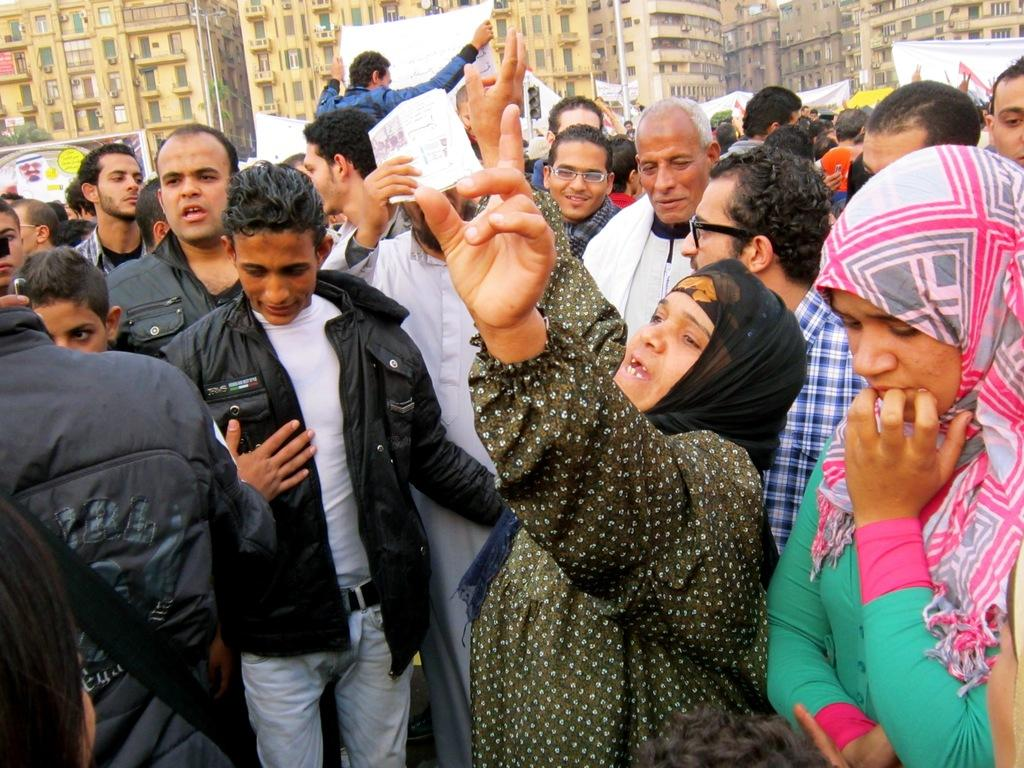What is the main subject of the image? The main subject of the image is a group of people. What are some of the people in the group holding? Some people in the group are holding white objects. What can be seen in the distance behind the group? There are buildings in the background of the image. What type of detail can be seen on the experience of the way the people are holding the white objects? There is no mention of a specific detail, experience, or way in the image. The image only shows a group of people holding white objects, and there is no additional information about how they are holding them or any experiences related to it. 